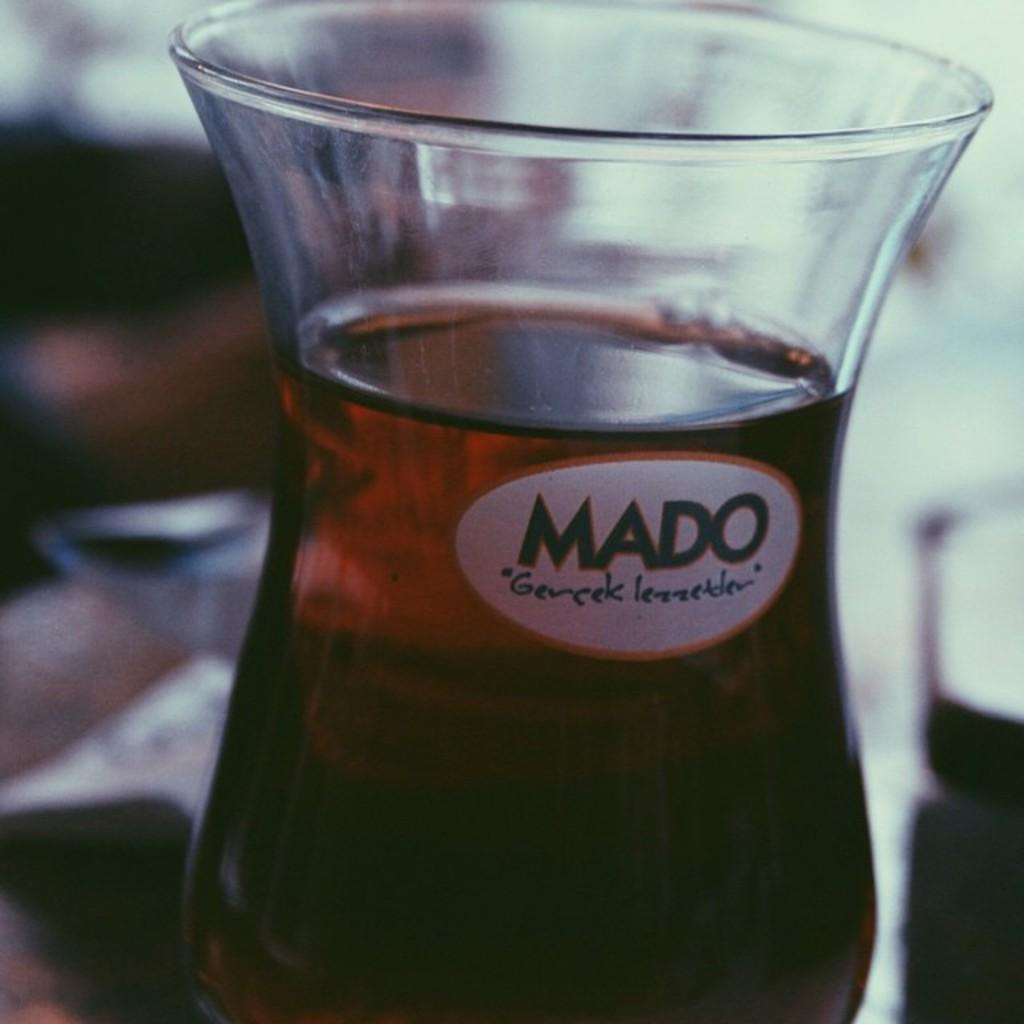<image>
Relay a brief, clear account of the picture shown. A beverage glass has the MADO Gercek Lezzetler logo on it. 